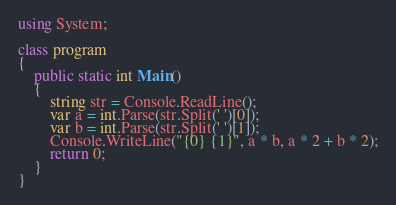Convert code to text. <code><loc_0><loc_0><loc_500><loc_500><_C#_>using System;

class program
{
    public static int Main()
    {
        string str = Console.ReadLine();
        var a = int.Parse(str.Split(' ')[0]);
        var b = int.Parse(str.Split(' ')[1]);
        Console.WriteLine("{0} {1}", a * b, a * 2 + b * 2);
        return 0;
    }
}</code> 